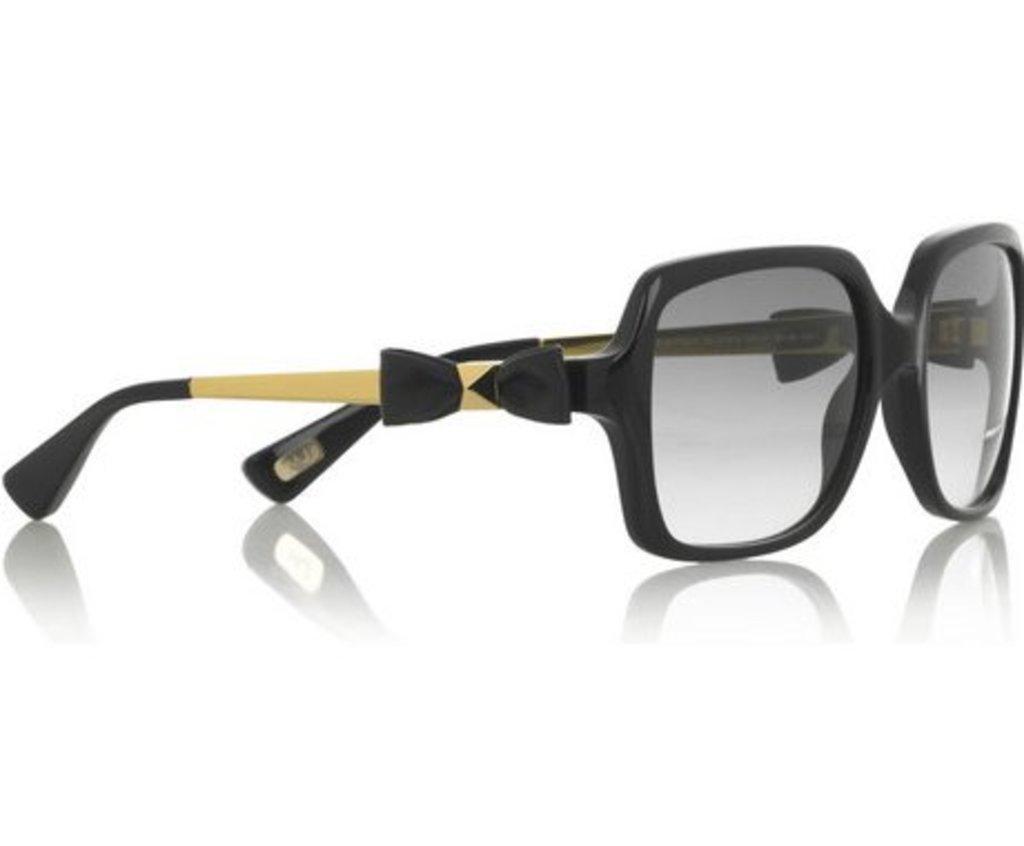Describe this image in one or two sentences. In this image we can see the sunglasses and there is a reflection of sunglasses at the bottom and the background is white in color. 